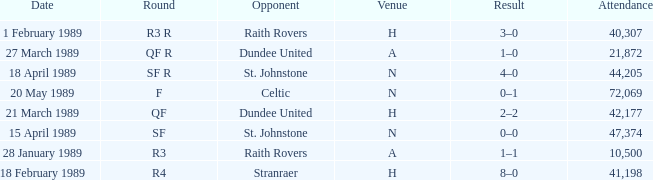On which date does the quarter-final round take place? 21 March 1989. I'm looking to parse the entire table for insights. Could you assist me with that? {'header': ['Date', 'Round', 'Opponent', 'Venue', 'Result', 'Attendance'], 'rows': [['1 February 1989', 'R3 R', 'Raith Rovers', 'H', '3–0', '40,307'], ['27 March 1989', 'QF R', 'Dundee United', 'A', '1–0', '21,872'], ['18 April 1989', 'SF R', 'St. Johnstone', 'N', '4–0', '44,205'], ['20 May 1989', 'F', 'Celtic', 'N', '0–1', '72,069'], ['21 March 1989', 'QF', 'Dundee United', 'H', '2–2', '42,177'], ['15 April 1989', 'SF', 'St. Johnstone', 'N', '0–0', '47,374'], ['28 January 1989', 'R3', 'Raith Rovers', 'A', '1–1', '10,500'], ['18 February 1989', 'R4', 'Stranraer', 'H', '8–0', '41,198']]} 